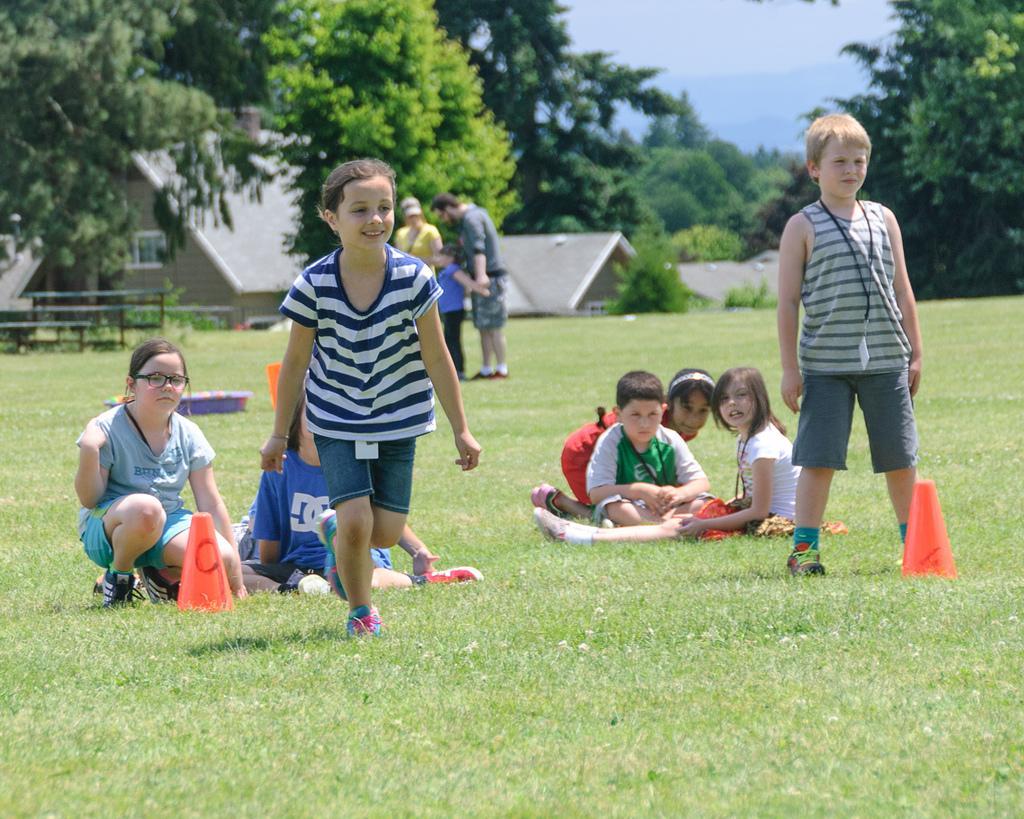Can you describe this image briefly? In this image we can see a few people are standing and few are sitting. And in front of them there are objects and grass. And at the back there are trees, Bench, House and a sky. 